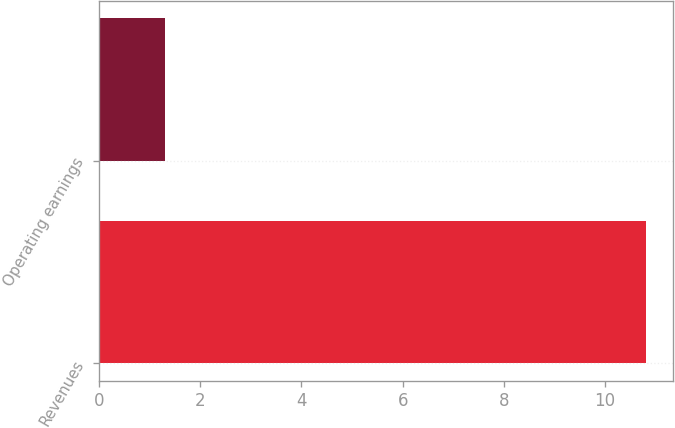<chart> <loc_0><loc_0><loc_500><loc_500><bar_chart><fcel>Revenues<fcel>Operating earnings<nl><fcel>10.8<fcel>1.3<nl></chart> 